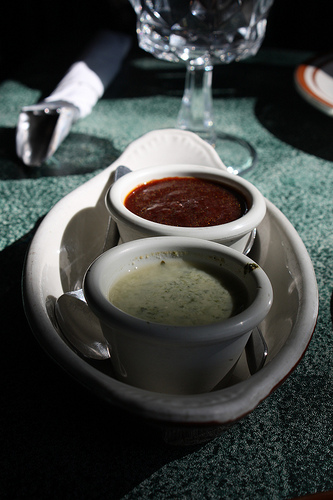<image>
Is there a food on the table? Yes. Looking at the image, I can see the food is positioned on top of the table, with the table providing support. Where is the ketchup in relation to the cup? Is it in the cup? No. The ketchup is not contained within the cup. These objects have a different spatial relationship. 